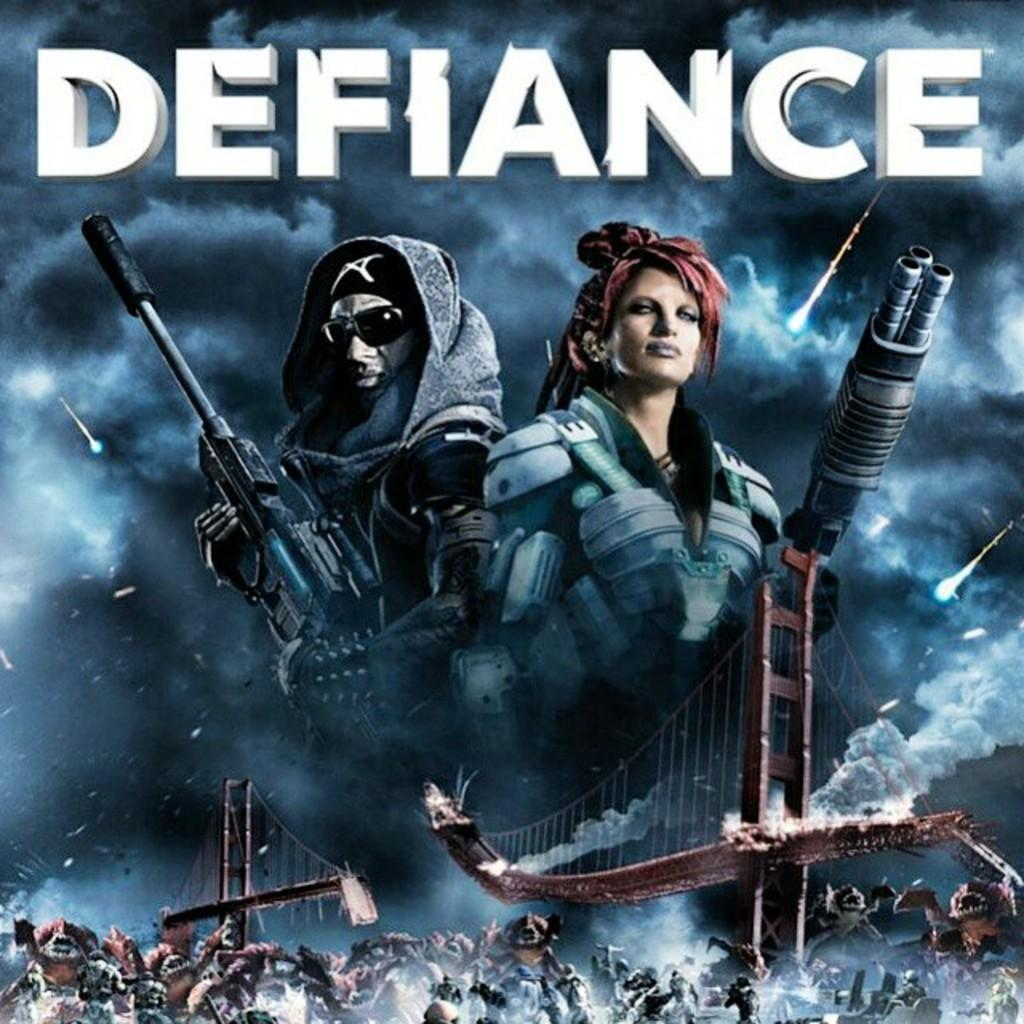Provide a one-sentence caption for the provided image. A poster for the game Defiance showing two people with guns and a battle scene. 